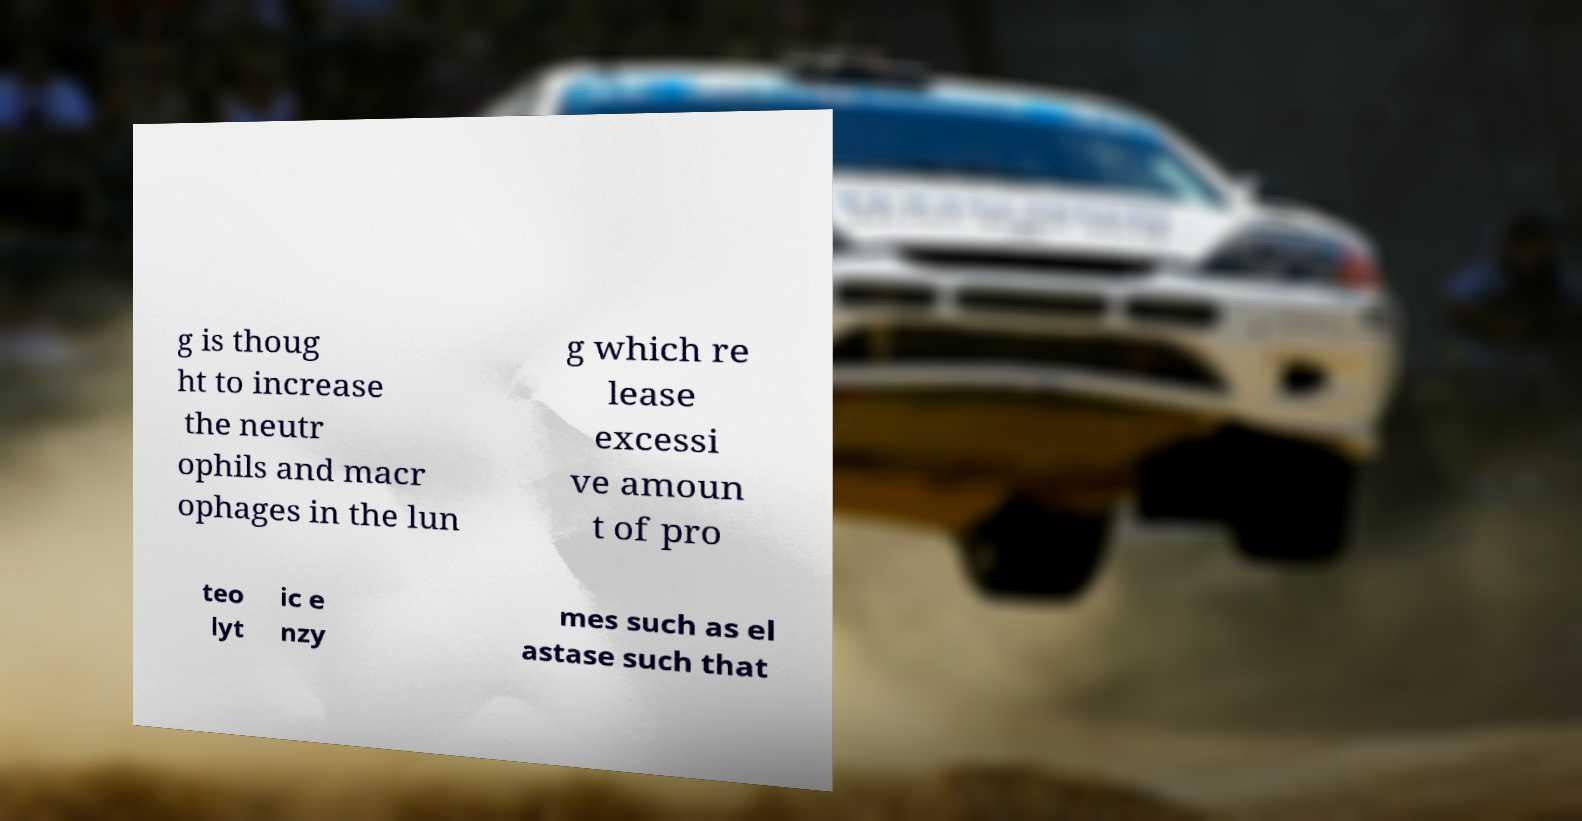I need the written content from this picture converted into text. Can you do that? g is thoug ht to increase the neutr ophils and macr ophages in the lun g which re lease excessi ve amoun t of pro teo lyt ic e nzy mes such as el astase such that 